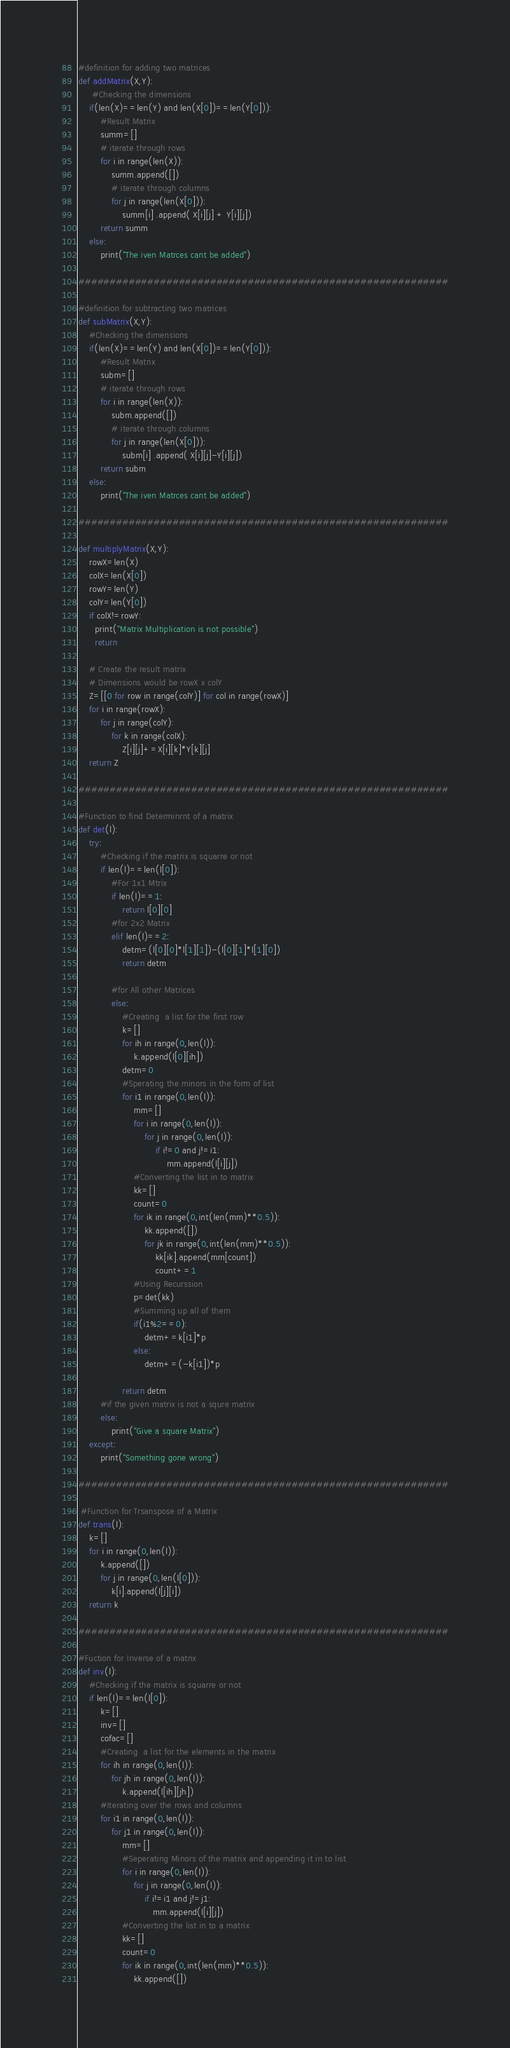Convert code to text. <code><loc_0><loc_0><loc_500><loc_500><_Python_>#definition for adding two matrices
def addMatrix(X,Y):
     #Checking the dimensions
    if(len(X)==len(Y) and len(X[0])==len(Y[0])):   
        #Result Matrix
        summ=[]        
        # iterate through rows
        for i in range(len(X)):
            summ.append([])
            # iterate through columns
            for j in range(len(X[0])):
                summ[i] .append( X[i][j] + Y[i][j])
        return summ
    else:
        print("The iven Matrces cant be added")
            
###########################################################
    
#definition for subtracting two matrices
def subMatrix(X,Y):
    #Checking the dimensions
    if(len(X)==len(Y) and len(X[0])==len(Y[0])):
        #Result Matrix
        subm=[]        
        # iterate through rows
        for i in range(len(X)):
            subm.append([])
            # iterate through columns
            for j in range(len(X[0])):
                subm[i] .append( X[i][j]-Y[i][j])
        return subm
    else:
        print("The iven Matrces cant be added")
            
###########################################################
    
def multiplyMatrix(X,Y):
    rowX=len(X)
    colX=len(X[0])
    rowY=len(Y)
    colY=len(Y[0])
    if colX!=rowY:
      print("Matrix Multiplication is not possible")
      return

    # Create the result matrix
    # Dimensions would be rowX x colY
    Z=[[0 for row in range(colY)] for col in range(rowX)]
    for i in range(rowX):
        for j in range(colY):
            for k in range(colX):
                Z[i][j]+=X[i][k]*Y[k][j]
    return Z
        
###########################################################
    
#Function to find Determinrnt of a matrix
def det(l):
    try:
        #Checking if the matrix is squarre or not
        if len(l)==len(l[0]):
            #For 1x1 Mtrix
            if len(l)==1:
                return l[0][0]
            #for 2x2 Matrix
            elif len(l)==2:
                detm=(l[0][0]*l[1][1])-(l[0][1]*l[1][0])
                return detm
                
            #for All other Matrices
            else:
                #Creating  a list for the first row
                k=[]
                for ih in range(0,len(l)):
                    k.append(l[0][ih])
                detm=0
                #Sperating the minors in the form of list
                for i1 in range(0,len(l)):
                    mm=[]
                    for i in range(0,len(l)):
                        for j in range(0,len(l)):
                            if i!=0 and j!=i1:
                                mm.append(l[i][j])
                    #Converting the list in to matrix
                    kk=[]
                    count=0
                    for ik in range(0,int(len(mm)**0.5)):
                        kk.append([])
                        for jk in range(0,int(len(mm)**0.5)):
                            kk[ik].append(mm[count])
                            count+=1
                    #Using Recurssion 
                    p=det(kk)
                    #Summing up all of them
                    if(i1%2==0):
                        detm+=k[i1]*p
                    else:
                        detm+=(-k[i1])*p
                    
                return detm
        #if the given matrix is not a squre matrix
        else:
            print("Give a square Matrix")
    except:
        print("Something gone wrong")
    
###########################################################
    
 #Function for Trsanspose of a Matrix       
def trans(l):
    k=[]
    for i in range(0,len(l)):
        k.append([])
        for j in range(0,len(l[0])):
            k[i].append(l[j][i])
    return k
        
###########################################################
    
#Fuction for Inverse of a matrix
def inv(l):
    #Checking if the matrix is squarre or not
    if len(l)==len(l[0]):
        k=[]
        inv=[]
        cofac=[]
        #Creating  a list for the elements in the matrix
        for ih in range(0,len(l)):
            for jh in range(0,len(l)):
                k.append(l[ih][jh])
        #Iterating over the rows and columns
        for i1 in range(0,len(l)):
            for j1 in range(0,len(l)):
                mm=[]
                #Seperating Minors of the matrix and appending it in to list
                for i in range(0,len(l)):
                    for j in range(0,len(l)):
                        if i!=i1 and j!=j1:
                           mm.append(l[i][j])
                #Converting the list in to a matrix 
                kk=[]
                count=0
                for ik in range(0,int(len(mm)**0.5)):
                    kk.append([])</code> 